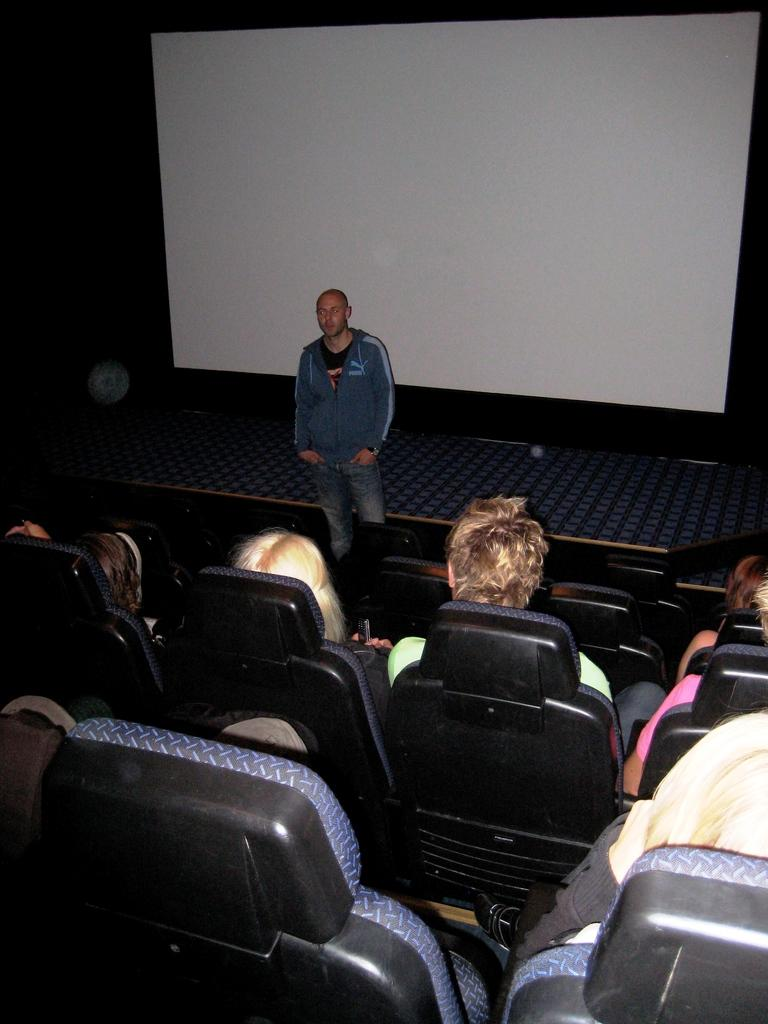What are the people in the image doing? The people in the image are sitting on chairs. Is there anyone standing in the image? Yes, one person is standing and talking in front of the seated people. What can be seen in the background of the image? There is a white color board visible in the background. What type of alarm is ringing in the image? There is no alarm present in the image. Can you tell me the name of the aunt who is sitting in the front row? There is no aunt mentioned or visible in the image. 